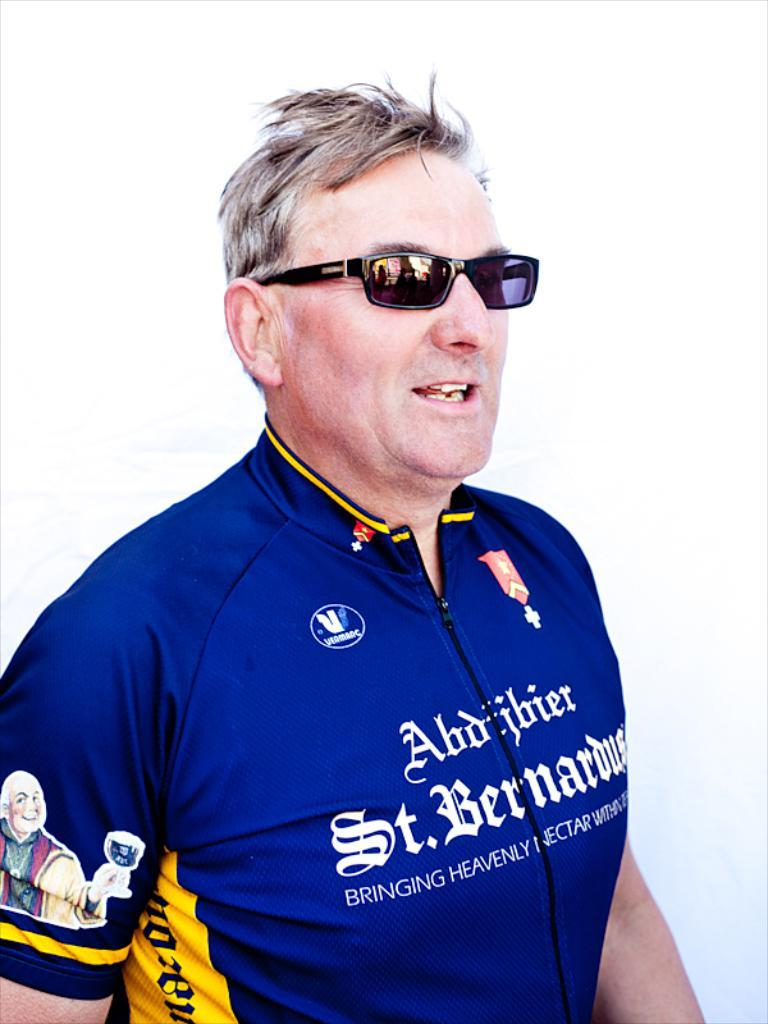<image>
Offer a succinct explanation of the picture presented. Man wearing a blue shirt which say St. Bernadus. 